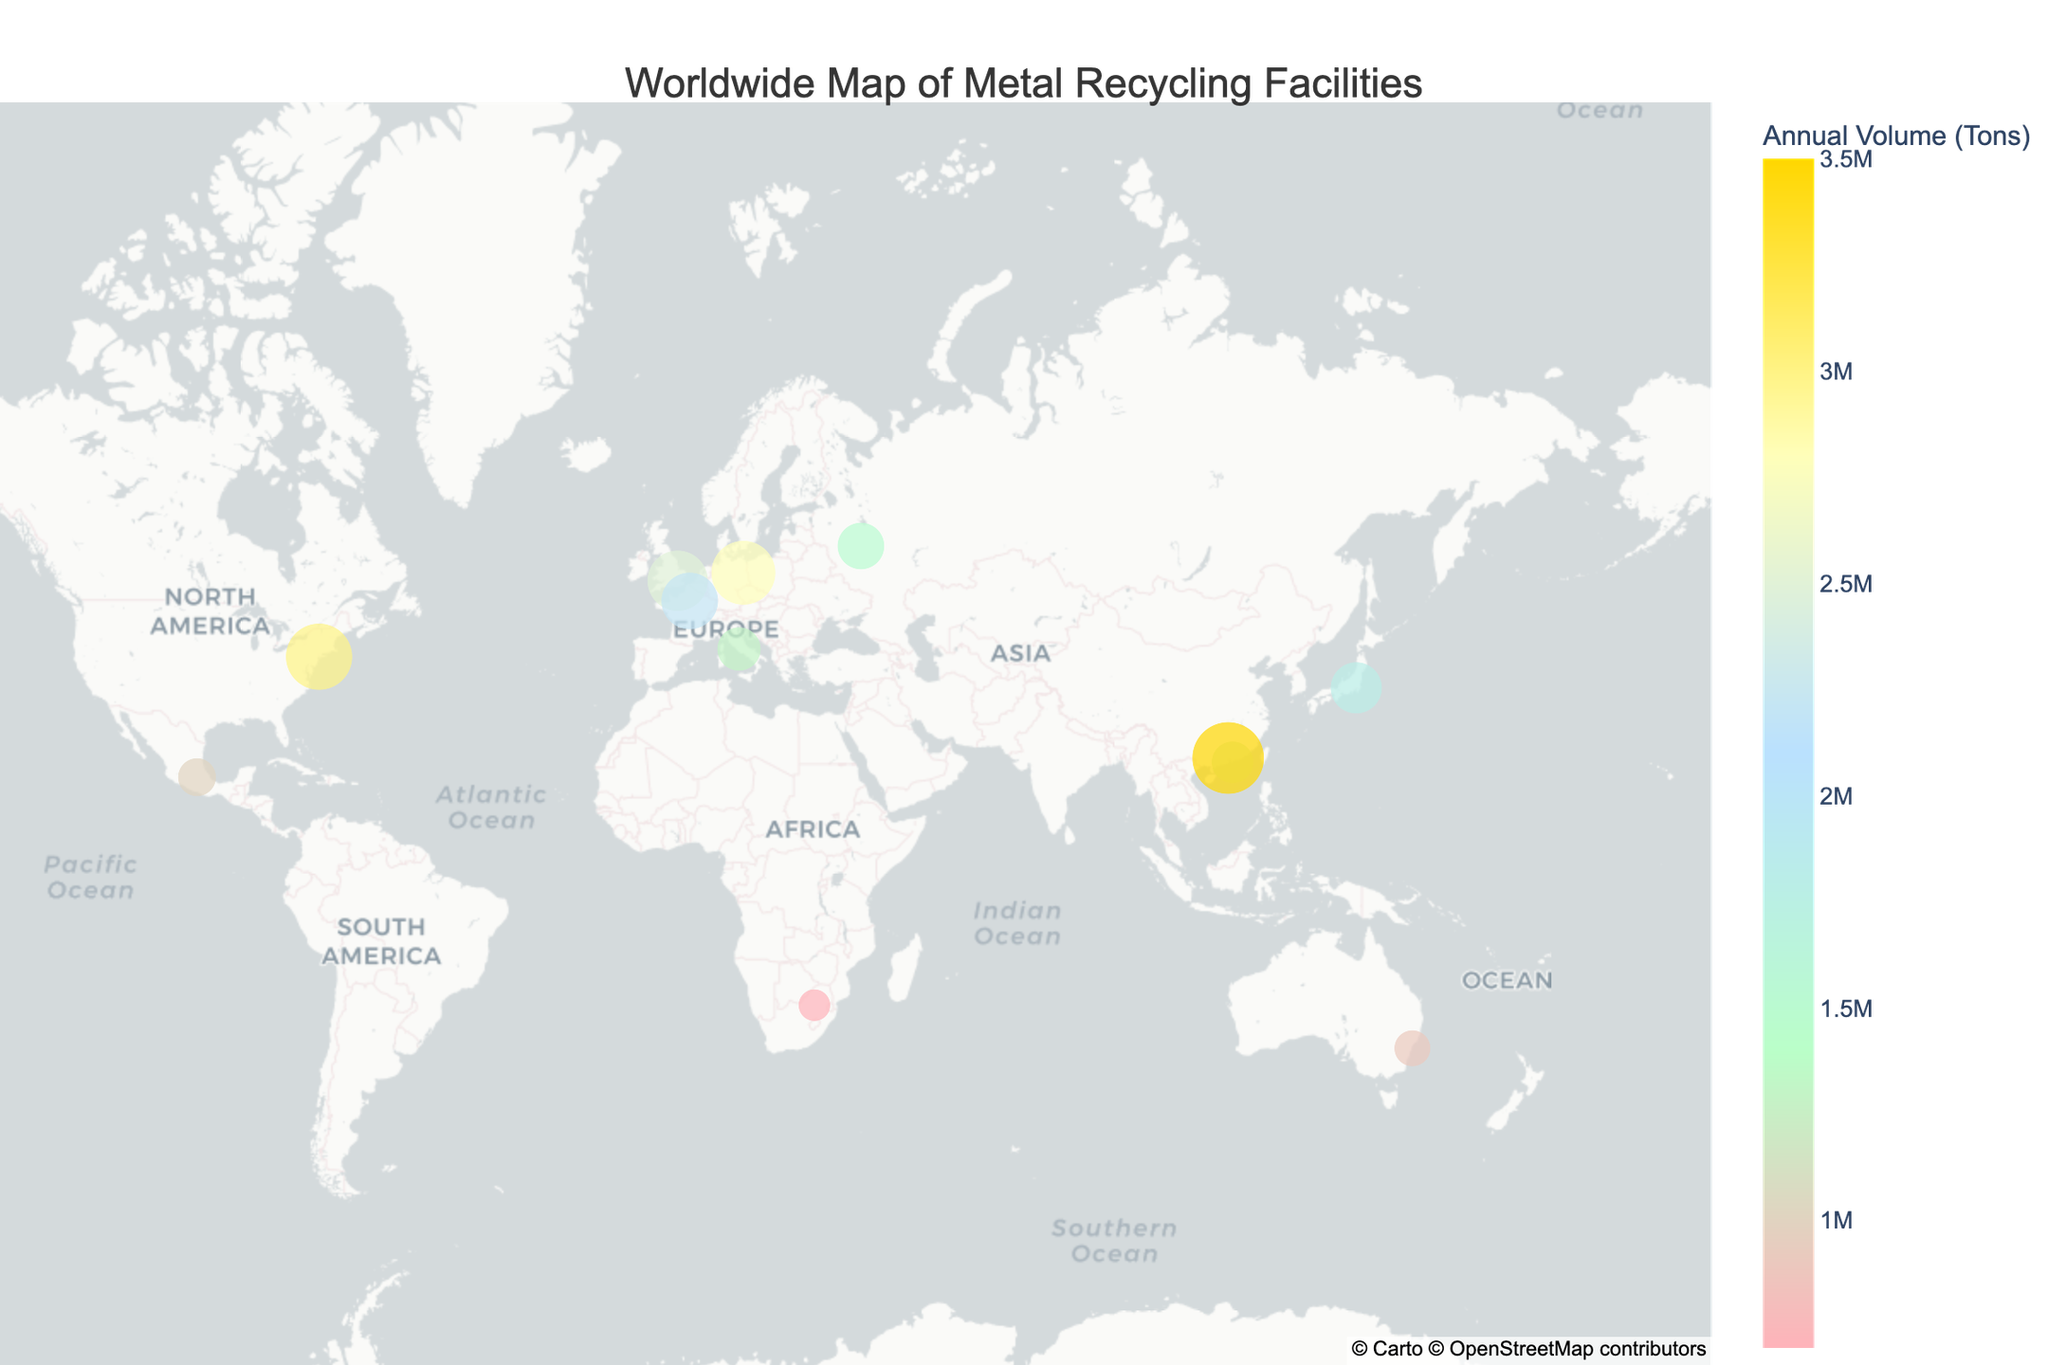What is the largest metal recycling facility in terms of annual volume processed? By looking at the visual representation, identify the facility with the largest size and highest value on the color scale.
Answer: Guangzhou Huishang Recycling What is the average annual volume processed by these facilities? Sum the annual volumes processed by all the facilities and divide by the number of facilities: (2500000 + 3000000 + 1800000 + 1200000 + 900000 + 2200000 + 1500000 + 2800000 + 1000000 + 3500000 + 700000 + 1300000) / 12.
Answer: 1825000 tons Which country has the most facilities listed on the map? Count the number of facilities in each country based on visual flags and labels.
Answer: None (each country has one listed) Which facility specializes in e-waste and metals and where is it located? Look for facilities with the "Specialty" attribute "e-waste and metals" and note the location from the hover information.
Answer: Chiho Environmental Group, Hong Kong What’s the combined annual volume of facilities specializing in steel? Identify facilities with "steel" in their specialty and sum their annual volumes: (1800000 + 900000 + 1000000 + 1300000).
Answer: 5000000 tons Which facility in Europe processes the most annually and what is its volume? Look for the largest facility on the map within Europe's geographic area, noting the size and color for the highest Annual Volume.
Answer: Alba Group, Germany, 2800000 tons What is the annual volume difference between Sims Metal Management in the United States and Vtormet in Russia? Subtract the annual volume of Vtormet from Sims Metal Management's annual volume: 3000000 - 1500000.
Answer: 1500000 tons Which two facilities are located in Asia? Identify facilities from hover names or locations that fall within Asian geographic boundaries.
Answer: Tokyo Steel Recycling Center, Japan and Guangzhou Huishang Recycling, China What does the color gold represent on the map? Refer to the color scale legend and identify the corresponding annual volume range for the color gold.
Answer: Higher annual volume (3500000 tons) 